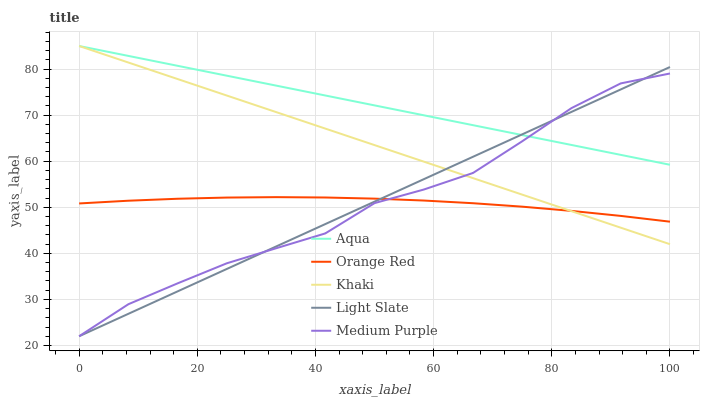Does Orange Red have the minimum area under the curve?
Answer yes or no. Yes. Does Aqua have the maximum area under the curve?
Answer yes or no. Yes. Does Medium Purple have the minimum area under the curve?
Answer yes or no. No. Does Medium Purple have the maximum area under the curve?
Answer yes or no. No. Is Aqua the smoothest?
Answer yes or no. Yes. Is Medium Purple the roughest?
Answer yes or no. Yes. Is Khaki the smoothest?
Answer yes or no. No. Is Khaki the roughest?
Answer yes or no. No. Does Khaki have the lowest value?
Answer yes or no. No. Does Aqua have the highest value?
Answer yes or no. Yes. Does Medium Purple have the highest value?
Answer yes or no. No. Is Orange Red less than Aqua?
Answer yes or no. Yes. Is Aqua greater than Orange Red?
Answer yes or no. Yes. Does Medium Purple intersect Aqua?
Answer yes or no. Yes. Is Medium Purple less than Aqua?
Answer yes or no. No. Is Medium Purple greater than Aqua?
Answer yes or no. No. Does Orange Red intersect Aqua?
Answer yes or no. No. 